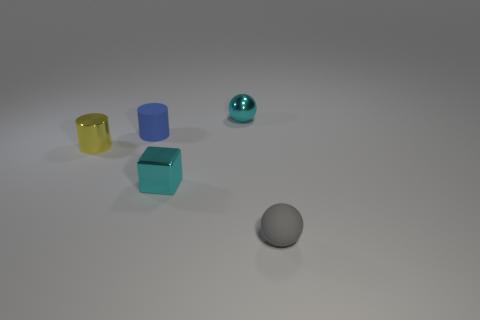Do the tiny block and the tiny metal sphere have the same color?
Your answer should be very brief. Yes. What shape is the cyan object that is the same material as the small block?
Ensure brevity in your answer.  Sphere. There is a small thing that is in front of the cyan cube; is there a tiny gray ball that is behind it?
Ensure brevity in your answer.  No. The cube is what size?
Keep it short and to the point. Small. What number of objects are either tiny cyan cubes or matte objects?
Offer a terse response. 3. Does the small sphere that is on the left side of the tiny gray matte ball have the same material as the small sphere in front of the small cyan cube?
Your answer should be compact. No. What is the color of the other object that is the same material as the small gray thing?
Offer a very short reply. Blue. What number of red rubber spheres are the same size as the blue rubber object?
Your answer should be compact. 0. How many other things are there of the same color as the shiny ball?
Your answer should be compact. 1. Are there any other things that have the same size as the gray rubber object?
Offer a very short reply. Yes. 